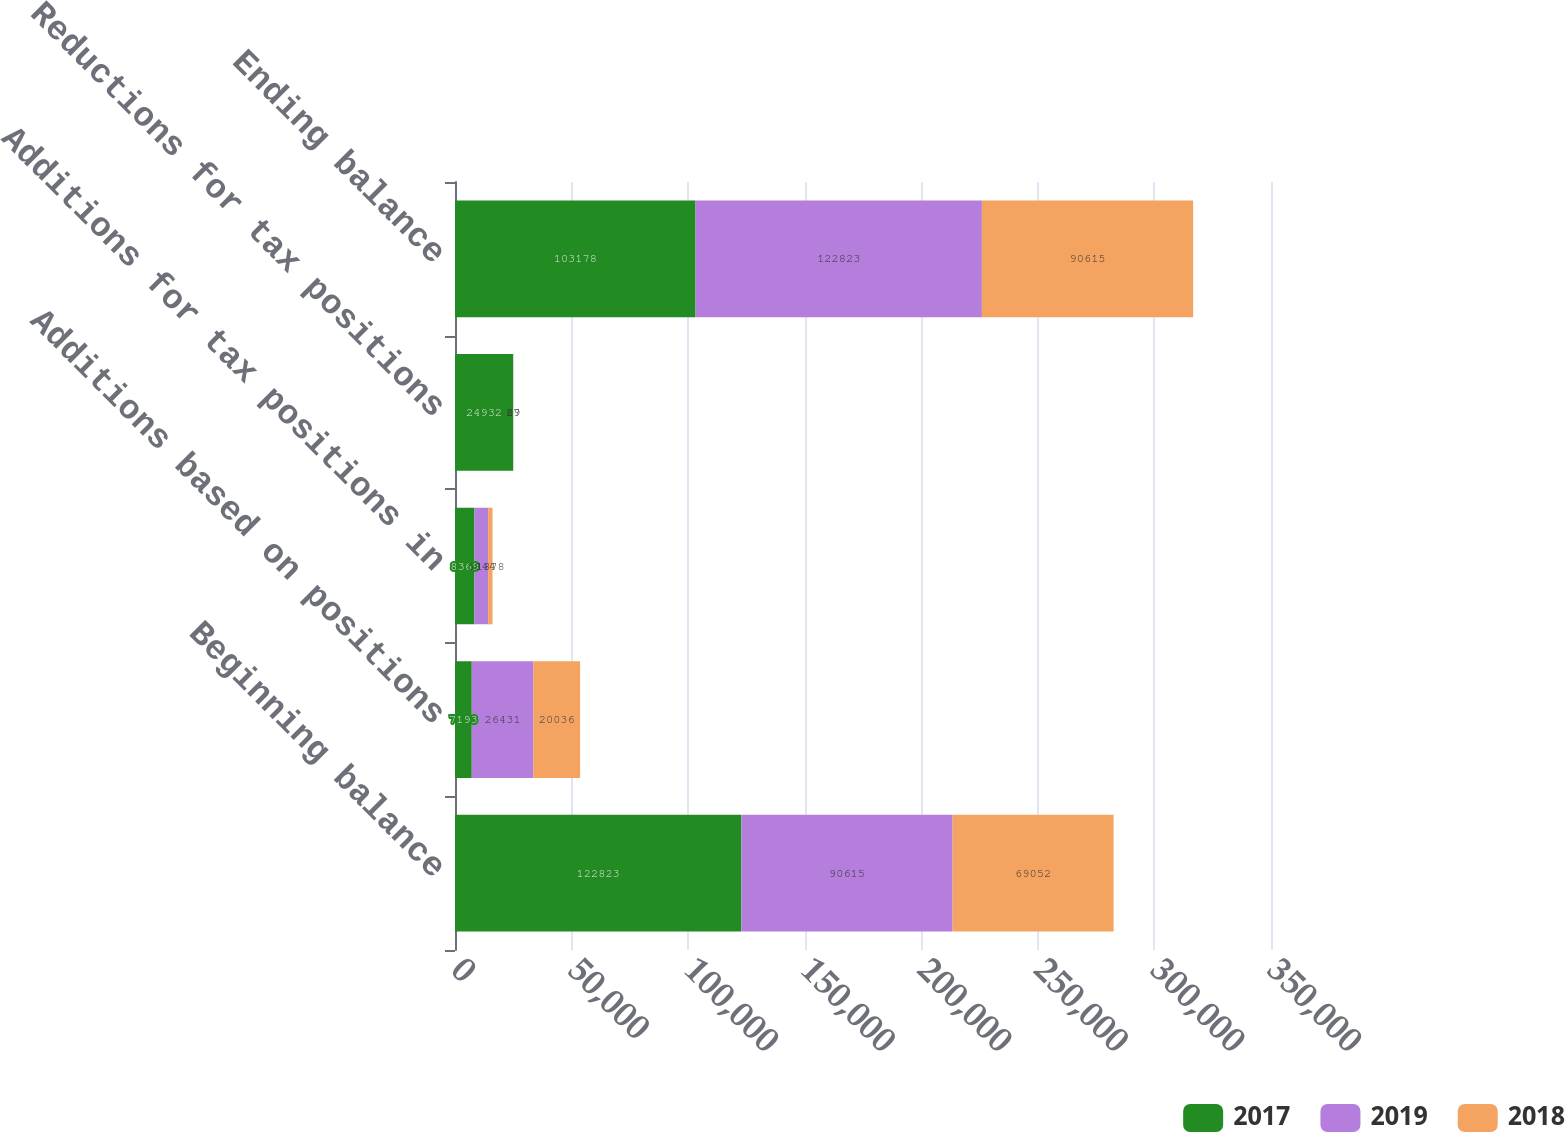<chart> <loc_0><loc_0><loc_500><loc_500><stacked_bar_chart><ecel><fcel>Beginning balance<fcel>Additions based on positions<fcel>Additions for tax positions in<fcel>Reductions for tax positions<fcel>Ending balance<nl><fcel>2017<fcel>122823<fcel>7193<fcel>8369<fcel>24932<fcel>103178<nl><fcel>2019<fcel>90615<fcel>26431<fcel>5844<fcel>67<fcel>122823<nl><fcel>2018<fcel>69052<fcel>20036<fcel>1878<fcel>29<fcel>90615<nl></chart> 